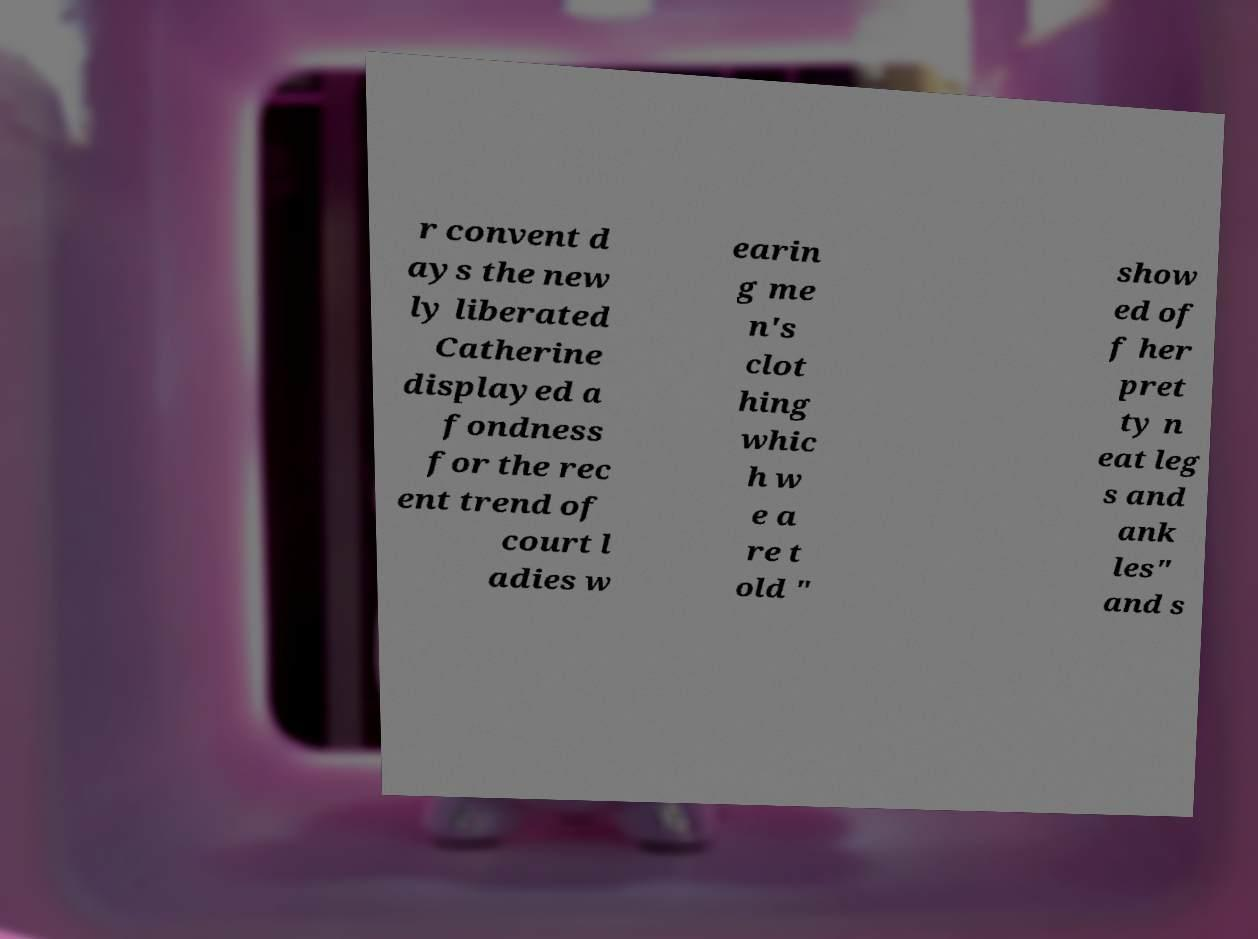For documentation purposes, I need the text within this image transcribed. Could you provide that? r convent d ays the new ly liberated Catherine displayed a fondness for the rec ent trend of court l adies w earin g me n's clot hing whic h w e a re t old " show ed of f her pret ty n eat leg s and ank les" and s 